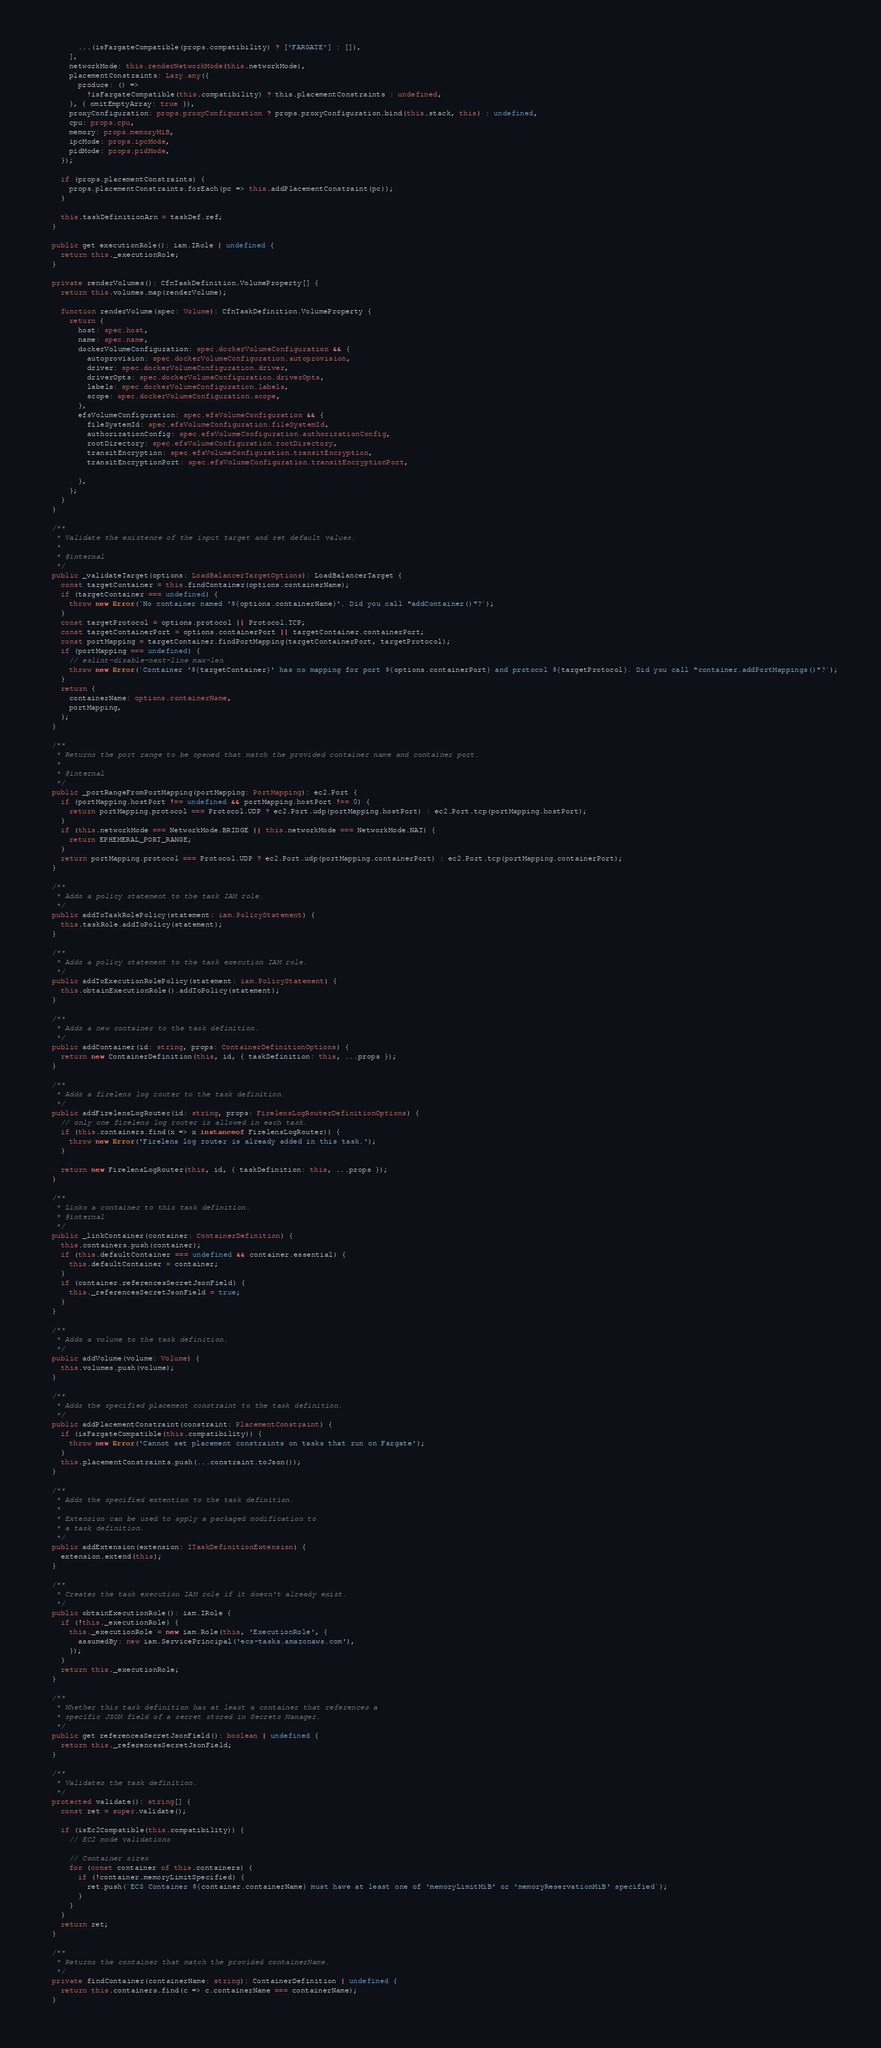Convert code to text. <code><loc_0><loc_0><loc_500><loc_500><_TypeScript_>        ...(isFargateCompatible(props.compatibility) ? ['FARGATE'] : []),
      ],
      networkMode: this.renderNetworkMode(this.networkMode),
      placementConstraints: Lazy.any({
        produce: () =>
          !isFargateCompatible(this.compatibility) ? this.placementConstraints : undefined,
      }, { omitEmptyArray: true }),
      proxyConfiguration: props.proxyConfiguration ? props.proxyConfiguration.bind(this.stack, this) : undefined,
      cpu: props.cpu,
      memory: props.memoryMiB,
      ipcMode: props.ipcMode,
      pidMode: props.pidMode,
    });

    if (props.placementConstraints) {
      props.placementConstraints.forEach(pc => this.addPlacementConstraint(pc));
    }

    this.taskDefinitionArn = taskDef.ref;
  }

  public get executionRole(): iam.IRole | undefined {
    return this._executionRole;
  }

  private renderVolumes(): CfnTaskDefinition.VolumeProperty[] {
    return this.volumes.map(renderVolume);

    function renderVolume(spec: Volume): CfnTaskDefinition.VolumeProperty {
      return {
        host: spec.host,
        name: spec.name,
        dockerVolumeConfiguration: spec.dockerVolumeConfiguration && {
          autoprovision: spec.dockerVolumeConfiguration.autoprovision,
          driver: spec.dockerVolumeConfiguration.driver,
          driverOpts: spec.dockerVolumeConfiguration.driverOpts,
          labels: spec.dockerVolumeConfiguration.labels,
          scope: spec.dockerVolumeConfiguration.scope,
        },
        efsVolumeConfiguration: spec.efsVolumeConfiguration && {
          fileSystemId: spec.efsVolumeConfiguration.fileSystemId,
          authorizationConfig: spec.efsVolumeConfiguration.authorizationConfig,
          rootDirectory: spec.efsVolumeConfiguration.rootDirectory,
          transitEncryption: spec.efsVolumeConfiguration.transitEncryption,
          transitEncryptionPort: spec.efsVolumeConfiguration.transitEncryptionPort,

        },
      };
    }
  }

  /**
   * Validate the existence of the input target and set default values.
   *
   * @internal
   */
  public _validateTarget(options: LoadBalancerTargetOptions): LoadBalancerTarget {
    const targetContainer = this.findContainer(options.containerName);
    if (targetContainer === undefined) {
      throw new Error(`No container named '${options.containerName}'. Did you call "addContainer()"?`);
    }
    const targetProtocol = options.protocol || Protocol.TCP;
    const targetContainerPort = options.containerPort || targetContainer.containerPort;
    const portMapping = targetContainer.findPortMapping(targetContainerPort, targetProtocol);
    if (portMapping === undefined) {
      // eslint-disable-next-line max-len
      throw new Error(`Container '${targetContainer}' has no mapping for port ${options.containerPort} and protocol ${targetProtocol}. Did you call "container.addPortMappings()"?`);
    }
    return {
      containerName: options.containerName,
      portMapping,
    };
  }

  /**
   * Returns the port range to be opened that match the provided container name and container port.
   *
   * @internal
   */
  public _portRangeFromPortMapping(portMapping: PortMapping): ec2.Port {
    if (portMapping.hostPort !== undefined && portMapping.hostPort !== 0) {
      return portMapping.protocol === Protocol.UDP ? ec2.Port.udp(portMapping.hostPort) : ec2.Port.tcp(portMapping.hostPort);
    }
    if (this.networkMode === NetworkMode.BRIDGE || this.networkMode === NetworkMode.NAT) {
      return EPHEMERAL_PORT_RANGE;
    }
    return portMapping.protocol === Protocol.UDP ? ec2.Port.udp(portMapping.containerPort) : ec2.Port.tcp(portMapping.containerPort);
  }

  /**
   * Adds a policy statement to the task IAM role.
   */
  public addToTaskRolePolicy(statement: iam.PolicyStatement) {
    this.taskRole.addToPolicy(statement);
  }

  /**
   * Adds a policy statement to the task execution IAM role.
   */
  public addToExecutionRolePolicy(statement: iam.PolicyStatement) {
    this.obtainExecutionRole().addToPolicy(statement);
  }

  /**
   * Adds a new container to the task definition.
   */
  public addContainer(id: string, props: ContainerDefinitionOptions) {
    return new ContainerDefinition(this, id, { taskDefinition: this, ...props });
  }

  /**
   * Adds a firelens log router to the task definition.
   */
  public addFirelensLogRouter(id: string, props: FirelensLogRouterDefinitionOptions) {
    // only one firelens log router is allowed in each task.
    if (this.containers.find(x => x instanceof FirelensLogRouter)) {
      throw new Error('Firelens log router is already added in this task.');
    }

    return new FirelensLogRouter(this, id, { taskDefinition: this, ...props });
  }

  /**
   * Links a container to this task definition.
   * @internal
   */
  public _linkContainer(container: ContainerDefinition) {
    this.containers.push(container);
    if (this.defaultContainer === undefined && container.essential) {
      this.defaultContainer = container;
    }
    if (container.referencesSecretJsonField) {
      this._referencesSecretJsonField = true;
    }
  }

  /**
   * Adds a volume to the task definition.
   */
  public addVolume(volume: Volume) {
    this.volumes.push(volume);
  }

  /**
   * Adds the specified placement constraint to the task definition.
   */
  public addPlacementConstraint(constraint: PlacementConstraint) {
    if (isFargateCompatible(this.compatibility)) {
      throw new Error('Cannot set placement constraints on tasks that run on Fargate');
    }
    this.placementConstraints.push(...constraint.toJson());
  }

  /**
   * Adds the specified extention to the task definition.
   *
   * Extension can be used to apply a packaged modification to
   * a task definition.
   */
  public addExtension(extension: ITaskDefinitionExtension) {
    extension.extend(this);
  }

  /**
   * Creates the task execution IAM role if it doesn't already exist.
   */
  public obtainExecutionRole(): iam.IRole {
    if (!this._executionRole) {
      this._executionRole = new iam.Role(this, 'ExecutionRole', {
        assumedBy: new iam.ServicePrincipal('ecs-tasks.amazonaws.com'),
      });
    }
    return this._executionRole;
  }

  /**
   * Whether this task definition has at least a container that references a
   * specific JSON field of a secret stored in Secrets Manager.
   */
  public get referencesSecretJsonField(): boolean | undefined {
    return this._referencesSecretJsonField;
  }

  /**
   * Validates the task definition.
   */
  protected validate(): string[] {
    const ret = super.validate();

    if (isEc2Compatible(this.compatibility)) {
      // EC2 mode validations

      // Container sizes
      for (const container of this.containers) {
        if (!container.memoryLimitSpecified) {
          ret.push(`ECS Container ${container.containerName} must have at least one of 'memoryLimitMiB' or 'memoryReservationMiB' specified`);
        }
      }
    }
    return ret;
  }

  /**
   * Returns the container that match the provided containerName.
   */
  private findContainer(containerName: string): ContainerDefinition | undefined {
    return this.containers.find(c => c.containerName === containerName);
  }
</code> 